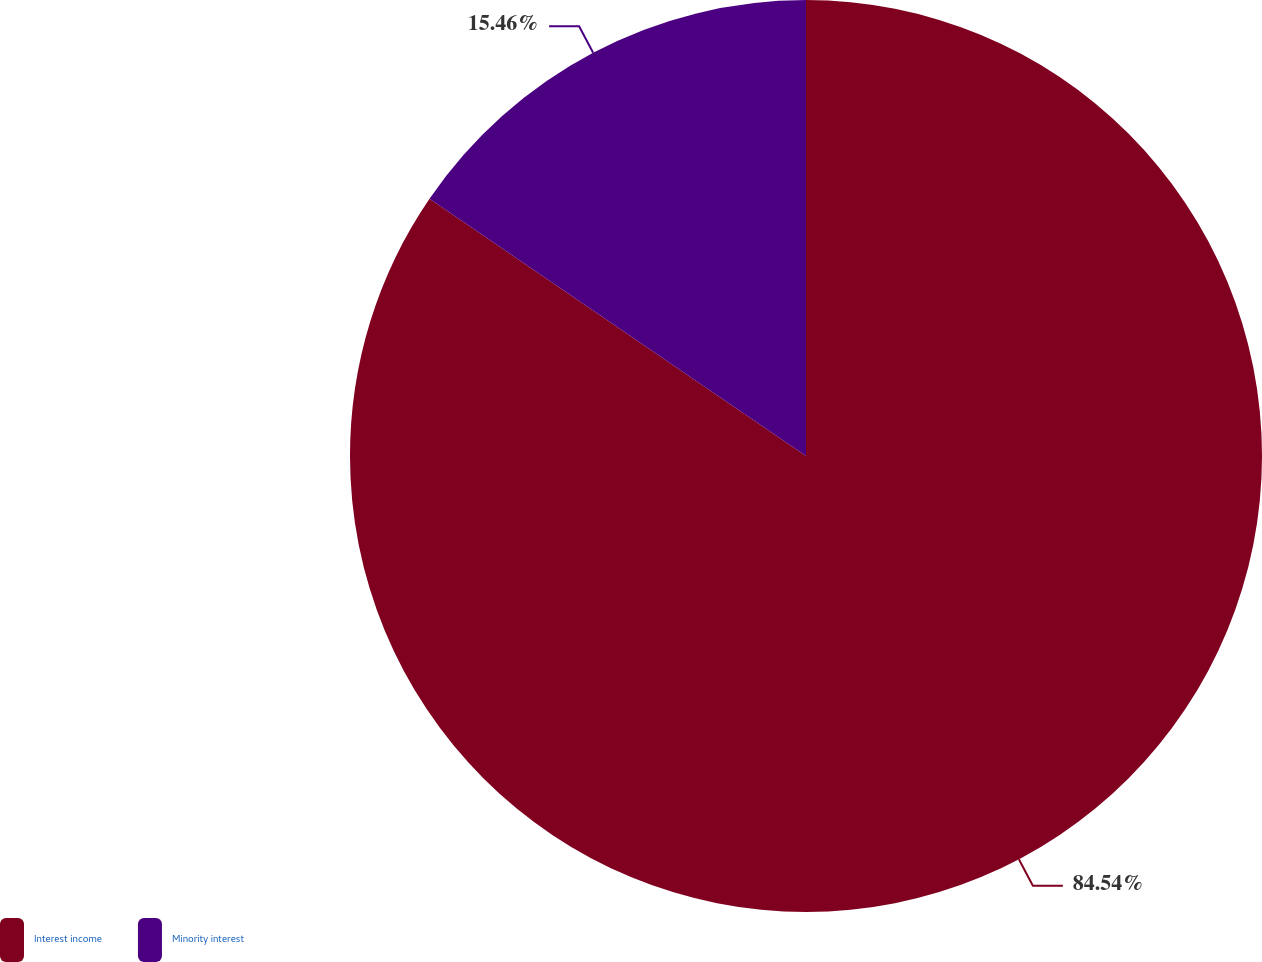Convert chart to OTSL. <chart><loc_0><loc_0><loc_500><loc_500><pie_chart><fcel>Interest income<fcel>Minority interest<nl><fcel>84.54%<fcel>15.46%<nl></chart> 